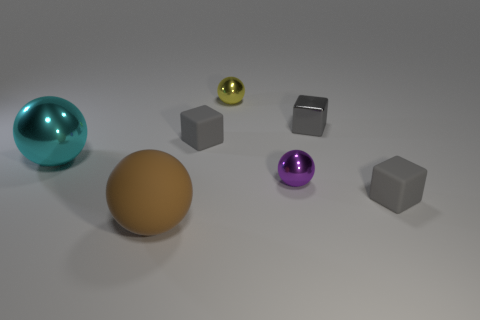Subtract all large metal spheres. How many spheres are left? 3 Add 1 small yellow shiny balls. How many objects exist? 8 Subtract all cyan balls. How many balls are left? 3 Subtract all blocks. How many objects are left? 4 Subtract all gray spheres. Subtract all cyan cylinders. How many spheres are left? 4 Subtract all small matte blocks. Subtract all small matte objects. How many objects are left? 3 Add 5 cyan balls. How many cyan balls are left? 6 Add 7 tiny yellow spheres. How many tiny yellow spheres exist? 8 Subtract 2 gray cubes. How many objects are left? 5 Subtract 3 balls. How many balls are left? 1 